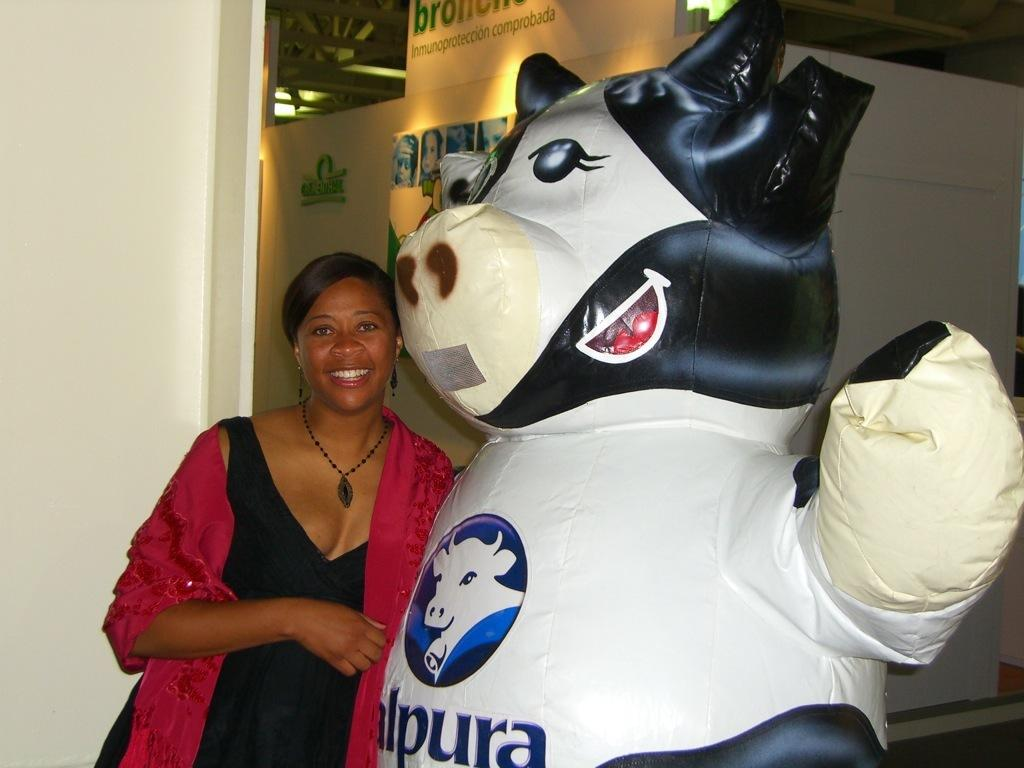<image>
Summarize the visual content of the image. A lady standing next to an inflatable Alpura cow 